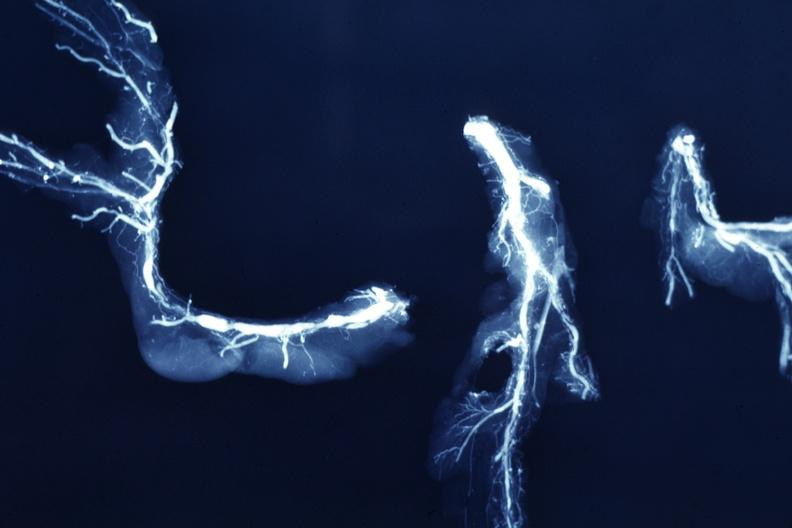s retroperitoneum present?
Answer the question using a single word or phrase. No 